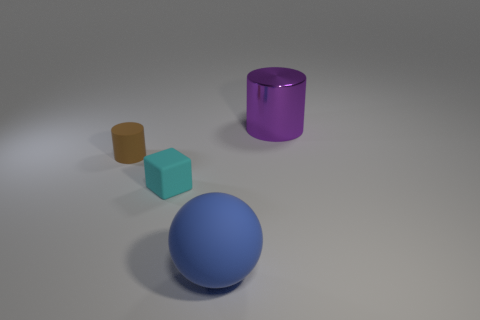What number of other things are the same shape as the cyan thing?
Your answer should be compact. 0. Is the number of small things that are on the right side of the blue rubber thing less than the number of large blue rubber things that are behind the tiny cyan thing?
Ensure brevity in your answer.  No. Is there any other thing that is the same material as the small cyan thing?
Provide a short and direct response. Yes. There is a large object that is made of the same material as the tiny brown thing; what is its shape?
Provide a succinct answer. Sphere. Is there any other thing of the same color as the big matte sphere?
Keep it short and to the point. No. What color is the cylinder in front of the big object that is behind the brown object?
Your response must be concise. Brown. The cylinder in front of the large thing behind the small thing behind the tiny cyan matte object is made of what material?
Provide a short and direct response. Rubber. How many blue rubber cylinders are the same size as the brown thing?
Ensure brevity in your answer.  0. What is the material of the thing that is behind the cyan cube and to the left of the rubber ball?
Make the answer very short. Rubber. There is a metallic object; how many large purple cylinders are in front of it?
Make the answer very short. 0. 